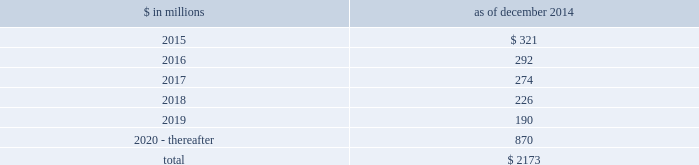Notes to consolidated financial statements sumitomo mitsui financial group , inc .
( smfg ) provides the firm with credit loss protection on certain approved loan commitments ( primarily investment-grade commercial lending commitments ) .
The notional amount of such loan commitments was $ 27.51 billion and $ 29.24 billion as of december 2014 and december 2013 , respectively .
The credit loss protection on loan commitments provided by smfg is generally limited to 95% ( 95 % ) of the first loss the firm realizes on such commitments , up to a maximum of approximately $ 950 million .
In addition , subject to the satisfaction of certain conditions , upon the firm 2019s request , smfg will provide protection for 70% ( 70 % ) of additional losses on such commitments , up to a maximum of $ 1.13 billion , of which $ 768 million and $ 870 million of protection had been provided as of december 2014 and december 2013 , respectively .
The firm also uses other financial instruments to mitigate credit risks related to certain commitments not covered by smfg .
These instruments primarily include credit default swaps that reference the same or similar underlying instrument or entity , or credit default swaps that reference a market index .
Warehouse financing .
The firm provides financing to clients who warehouse financial assets .
These arrangements are secured by the warehoused assets , primarily consisting of corporate loans and commercial mortgage loans .
Contingent and forward starting resale and securities borrowing agreements/forward starting repurchase and secured lending agreements the firm enters into resale and securities borrowing agreements and repurchase and secured lending agreements that settle at a future date , generally within three business days .
The firm also enters into commitments to provide contingent financing to its clients and counterparties through resale agreements .
The firm 2019s funding of these commitments depends on the satisfaction of all contractual conditions to the resale agreement and these commitments can expire unused .
Letters of credit the firm has commitments under letters of credit issued by various banks which the firm provides to counterparties in lieu of securities or cash to satisfy various collateral and margin deposit requirements .
Investment commitments the firm 2019s investment commitments of $ 5.16 billion and $ 7.12 billion as of december 2014 and december 2013 , respectively , include commitments to invest in private equity , real estate and other assets directly and through funds that the firm raises and manages .
Of these amounts , $ 2.87 billion and $ 5.48 billion as of december 2014 and december 2013 , respectively , relate to commitments to invest in funds managed by the firm .
If these commitments are called , they would be funded at market value on the date of investment .
Leases the firm has contractual obligations under long-term noncancelable lease agreements , principally for office space , expiring on various dates through 2069 .
Certain agreements are subject to periodic escalation provisions for increases in real estate taxes and other charges .
The table below presents future minimum rental payments , net of minimum sublease rentals .
$ in millions december 2014 .
Rent charged to operating expense was $ 309 million for 2014 , $ 324 million for 2013 and $ 374 million for 2012 .
Operating leases include office space held in excess of current requirements .
Rent expense relating to space held for growth is included in 201coccupancy . 201d the firm records a liability , based on the fair value of the remaining lease rentals reduced by any potential or existing sublease rentals , for leases where the firm has ceased using the space and management has concluded that the firm will not derive any future economic benefits .
Costs to terminate a lease before the end of its term are recognized and measured at fair value on termination .
Goldman sachs 2014 annual report 165 .
What percentage of future minimum rental payments is due after 2019? 
Computations: (870 / 2173)
Answer: 0.40037. 